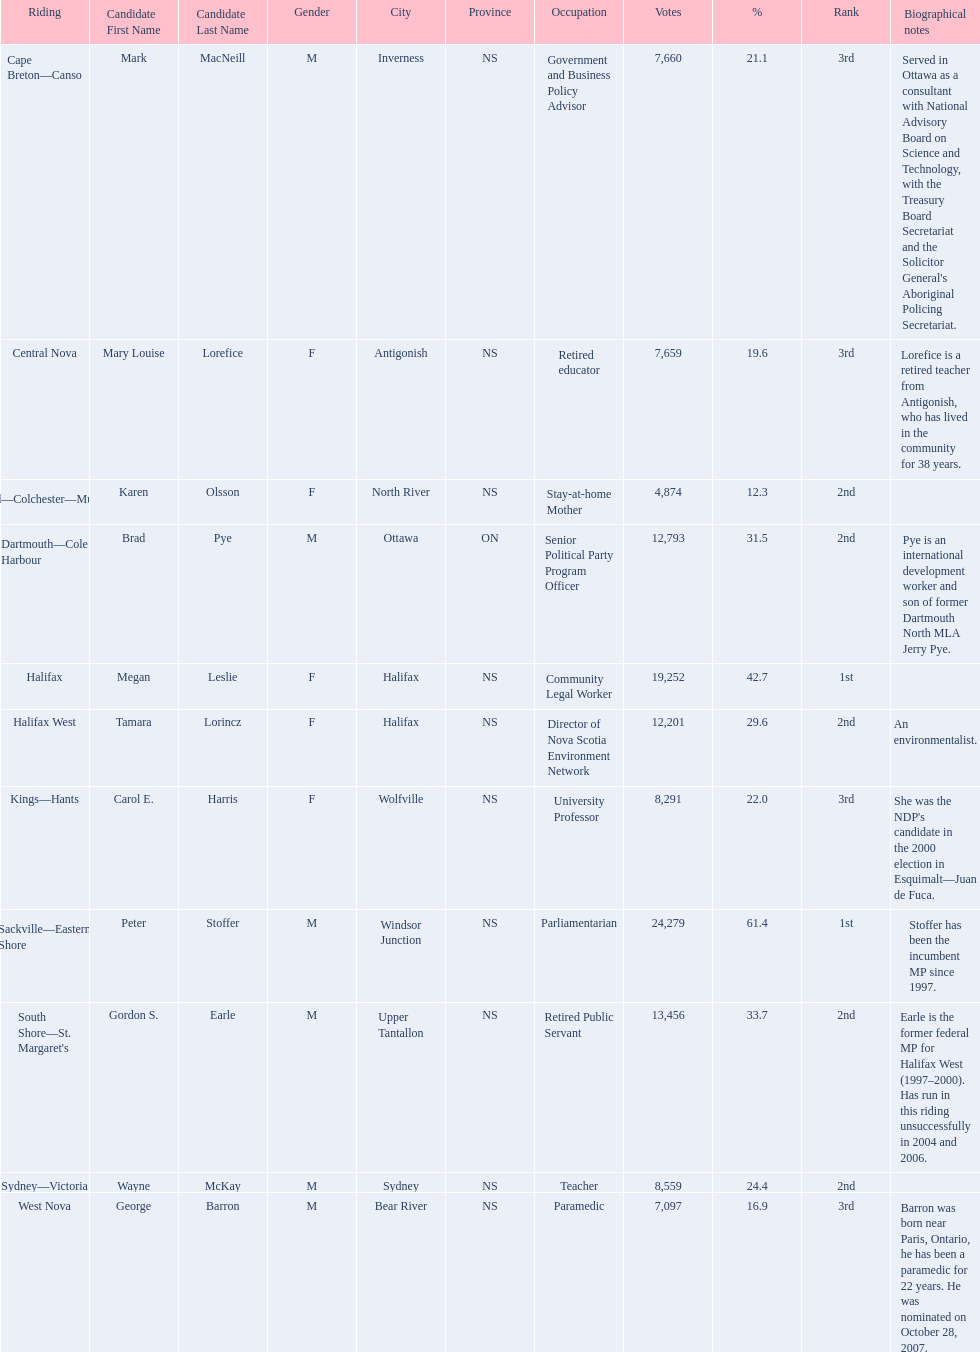What is the total number of candidates? 11. 